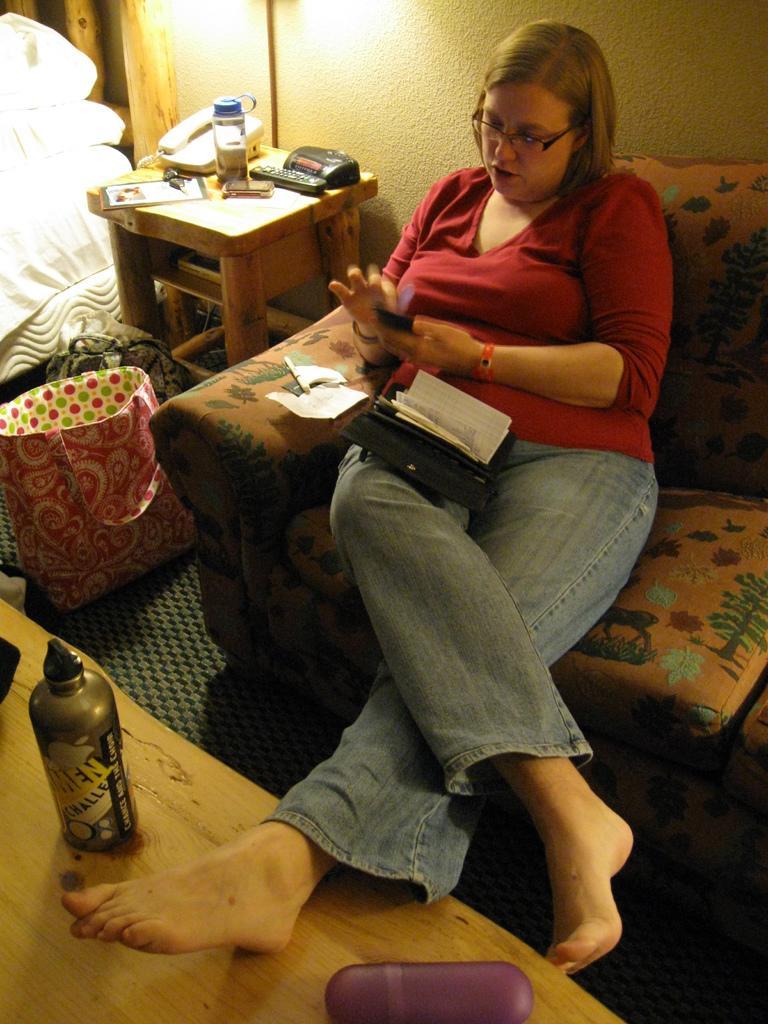In one or two sentences, can you explain what this image depicts? In this image I see a woman who is sitting on a couch and she kept her legs on the table and on the left there is a stool over here and there are few things on it and there is a cover. In the background I see the wall. 